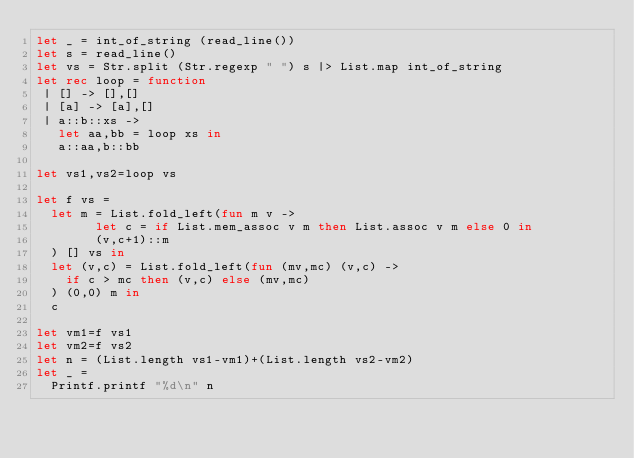<code> <loc_0><loc_0><loc_500><loc_500><_OCaml_>let _ = int_of_string (read_line())
let s = read_line()
let vs = Str.split (Str.regexp " ") s |> List.map int_of_string
let rec loop = function
 | [] -> [],[]
 | [a] -> [a],[]
 | a::b::xs ->
   let aa,bb = loop xs in
   a::aa,b::bb

let vs1,vs2=loop vs

let f vs =
  let m = List.fold_left(fun m v ->
        let c = if List.mem_assoc v m then List.assoc v m else 0 in
        (v,c+1)::m
  ) [] vs in
  let (v,c) = List.fold_left(fun (mv,mc) (v,c) ->
    if c > mc then (v,c) else (mv,mc)
  ) (0,0) m in
  c

let vm1=f vs1
let vm2=f vs2
let n = (List.length vs1-vm1)+(List.length vs2-vm2)
let _ =
  Printf.printf "%d\n" n
</code> 